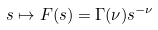Convert formula to latex. <formula><loc_0><loc_0><loc_500><loc_500>s \mapsto F ( s ) = \Gamma ( \nu ) s ^ { - \nu }</formula> 